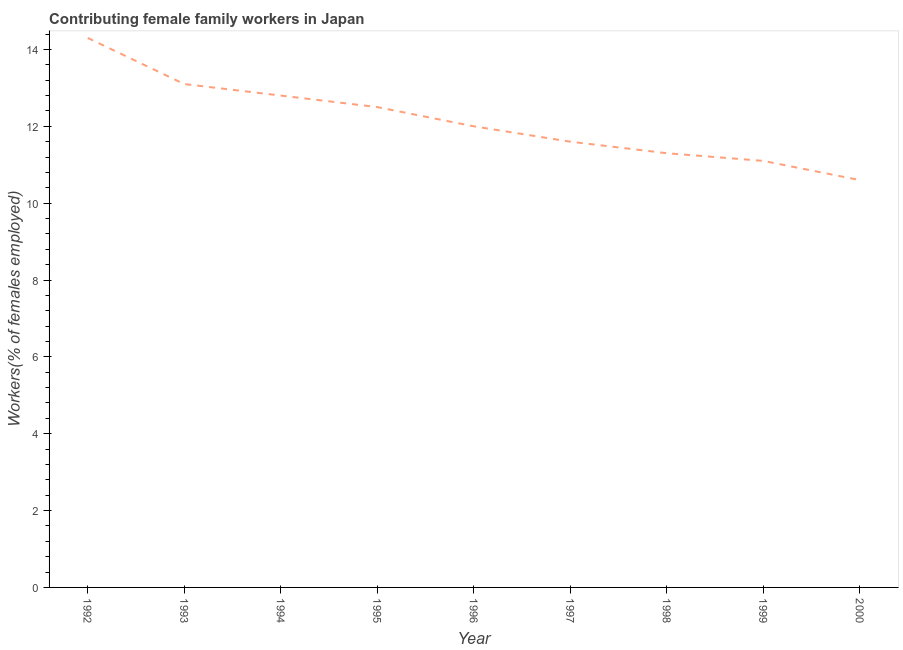What is the contributing female family workers in 1992?
Ensure brevity in your answer.  14.3. Across all years, what is the maximum contributing female family workers?
Ensure brevity in your answer.  14.3. Across all years, what is the minimum contributing female family workers?
Provide a short and direct response. 10.6. In which year was the contributing female family workers minimum?
Your response must be concise. 2000. What is the sum of the contributing female family workers?
Your response must be concise. 109.3. What is the difference between the contributing female family workers in 1992 and 1999?
Offer a very short reply. 3.2. What is the average contributing female family workers per year?
Your answer should be compact. 12.14. What is the ratio of the contributing female family workers in 1992 to that in 1996?
Your response must be concise. 1.19. Is the difference between the contributing female family workers in 1994 and 1998 greater than the difference between any two years?
Offer a terse response. No. What is the difference between the highest and the second highest contributing female family workers?
Your answer should be very brief. 1.2. Is the sum of the contributing female family workers in 1995 and 2000 greater than the maximum contributing female family workers across all years?
Give a very brief answer. Yes. What is the difference between the highest and the lowest contributing female family workers?
Ensure brevity in your answer.  3.7. How many years are there in the graph?
Offer a terse response. 9. What is the difference between two consecutive major ticks on the Y-axis?
Offer a very short reply. 2. Are the values on the major ticks of Y-axis written in scientific E-notation?
Offer a very short reply. No. Does the graph contain grids?
Offer a terse response. No. What is the title of the graph?
Ensure brevity in your answer.  Contributing female family workers in Japan. What is the label or title of the Y-axis?
Keep it short and to the point. Workers(% of females employed). What is the Workers(% of females employed) of 1992?
Your answer should be very brief. 14.3. What is the Workers(% of females employed) in 1993?
Provide a short and direct response. 13.1. What is the Workers(% of females employed) in 1994?
Provide a succinct answer. 12.8. What is the Workers(% of females employed) in 1995?
Your answer should be very brief. 12.5. What is the Workers(% of females employed) in 1997?
Make the answer very short. 11.6. What is the Workers(% of females employed) in 1998?
Ensure brevity in your answer.  11.3. What is the Workers(% of females employed) in 1999?
Your answer should be compact. 11.1. What is the Workers(% of females employed) of 2000?
Offer a terse response. 10.6. What is the difference between the Workers(% of females employed) in 1992 and 1993?
Offer a very short reply. 1.2. What is the difference between the Workers(% of females employed) in 1992 and 1994?
Provide a short and direct response. 1.5. What is the difference between the Workers(% of females employed) in 1992 and 1995?
Keep it short and to the point. 1.8. What is the difference between the Workers(% of females employed) in 1992 and 1999?
Your answer should be compact. 3.2. What is the difference between the Workers(% of females employed) in 1993 and 1994?
Make the answer very short. 0.3. What is the difference between the Workers(% of females employed) in 1993 and 1999?
Your answer should be very brief. 2. What is the difference between the Workers(% of females employed) in 1993 and 2000?
Keep it short and to the point. 2.5. What is the difference between the Workers(% of females employed) in 1994 and 1995?
Your answer should be very brief. 0.3. What is the difference between the Workers(% of females employed) in 1994 and 1996?
Provide a short and direct response. 0.8. What is the difference between the Workers(% of females employed) in 1994 and 1998?
Your answer should be compact. 1.5. What is the difference between the Workers(% of females employed) in 1995 and 1997?
Offer a very short reply. 0.9. What is the difference between the Workers(% of females employed) in 1996 and 1997?
Make the answer very short. 0.4. What is the difference between the Workers(% of females employed) in 1996 and 1998?
Provide a succinct answer. 0.7. What is the difference between the Workers(% of females employed) in 1997 and 1998?
Ensure brevity in your answer.  0.3. What is the difference between the Workers(% of females employed) in 1997 and 2000?
Make the answer very short. 1. What is the difference between the Workers(% of females employed) in 1998 and 1999?
Offer a very short reply. 0.2. What is the difference between the Workers(% of females employed) in 1998 and 2000?
Offer a terse response. 0.7. What is the ratio of the Workers(% of females employed) in 1992 to that in 1993?
Keep it short and to the point. 1.09. What is the ratio of the Workers(% of females employed) in 1992 to that in 1994?
Offer a terse response. 1.12. What is the ratio of the Workers(% of females employed) in 1992 to that in 1995?
Your answer should be very brief. 1.14. What is the ratio of the Workers(% of females employed) in 1992 to that in 1996?
Your answer should be compact. 1.19. What is the ratio of the Workers(% of females employed) in 1992 to that in 1997?
Your answer should be compact. 1.23. What is the ratio of the Workers(% of females employed) in 1992 to that in 1998?
Provide a succinct answer. 1.26. What is the ratio of the Workers(% of females employed) in 1992 to that in 1999?
Provide a short and direct response. 1.29. What is the ratio of the Workers(% of females employed) in 1992 to that in 2000?
Offer a very short reply. 1.35. What is the ratio of the Workers(% of females employed) in 1993 to that in 1994?
Your answer should be compact. 1.02. What is the ratio of the Workers(% of females employed) in 1993 to that in 1995?
Give a very brief answer. 1.05. What is the ratio of the Workers(% of females employed) in 1993 to that in 1996?
Offer a terse response. 1.09. What is the ratio of the Workers(% of females employed) in 1993 to that in 1997?
Keep it short and to the point. 1.13. What is the ratio of the Workers(% of females employed) in 1993 to that in 1998?
Ensure brevity in your answer.  1.16. What is the ratio of the Workers(% of females employed) in 1993 to that in 1999?
Offer a terse response. 1.18. What is the ratio of the Workers(% of females employed) in 1993 to that in 2000?
Your response must be concise. 1.24. What is the ratio of the Workers(% of females employed) in 1994 to that in 1995?
Offer a very short reply. 1.02. What is the ratio of the Workers(% of females employed) in 1994 to that in 1996?
Give a very brief answer. 1.07. What is the ratio of the Workers(% of females employed) in 1994 to that in 1997?
Offer a very short reply. 1.1. What is the ratio of the Workers(% of females employed) in 1994 to that in 1998?
Keep it short and to the point. 1.13. What is the ratio of the Workers(% of females employed) in 1994 to that in 1999?
Ensure brevity in your answer.  1.15. What is the ratio of the Workers(% of females employed) in 1994 to that in 2000?
Your response must be concise. 1.21. What is the ratio of the Workers(% of females employed) in 1995 to that in 1996?
Offer a very short reply. 1.04. What is the ratio of the Workers(% of females employed) in 1995 to that in 1997?
Provide a succinct answer. 1.08. What is the ratio of the Workers(% of females employed) in 1995 to that in 1998?
Give a very brief answer. 1.11. What is the ratio of the Workers(% of females employed) in 1995 to that in 1999?
Offer a very short reply. 1.13. What is the ratio of the Workers(% of females employed) in 1995 to that in 2000?
Your answer should be very brief. 1.18. What is the ratio of the Workers(% of females employed) in 1996 to that in 1997?
Make the answer very short. 1.03. What is the ratio of the Workers(% of females employed) in 1996 to that in 1998?
Provide a succinct answer. 1.06. What is the ratio of the Workers(% of females employed) in 1996 to that in 1999?
Keep it short and to the point. 1.08. What is the ratio of the Workers(% of females employed) in 1996 to that in 2000?
Your answer should be very brief. 1.13. What is the ratio of the Workers(% of females employed) in 1997 to that in 1999?
Keep it short and to the point. 1.04. What is the ratio of the Workers(% of females employed) in 1997 to that in 2000?
Your response must be concise. 1.09. What is the ratio of the Workers(% of females employed) in 1998 to that in 1999?
Provide a short and direct response. 1.02. What is the ratio of the Workers(% of females employed) in 1998 to that in 2000?
Keep it short and to the point. 1.07. What is the ratio of the Workers(% of females employed) in 1999 to that in 2000?
Offer a terse response. 1.05. 